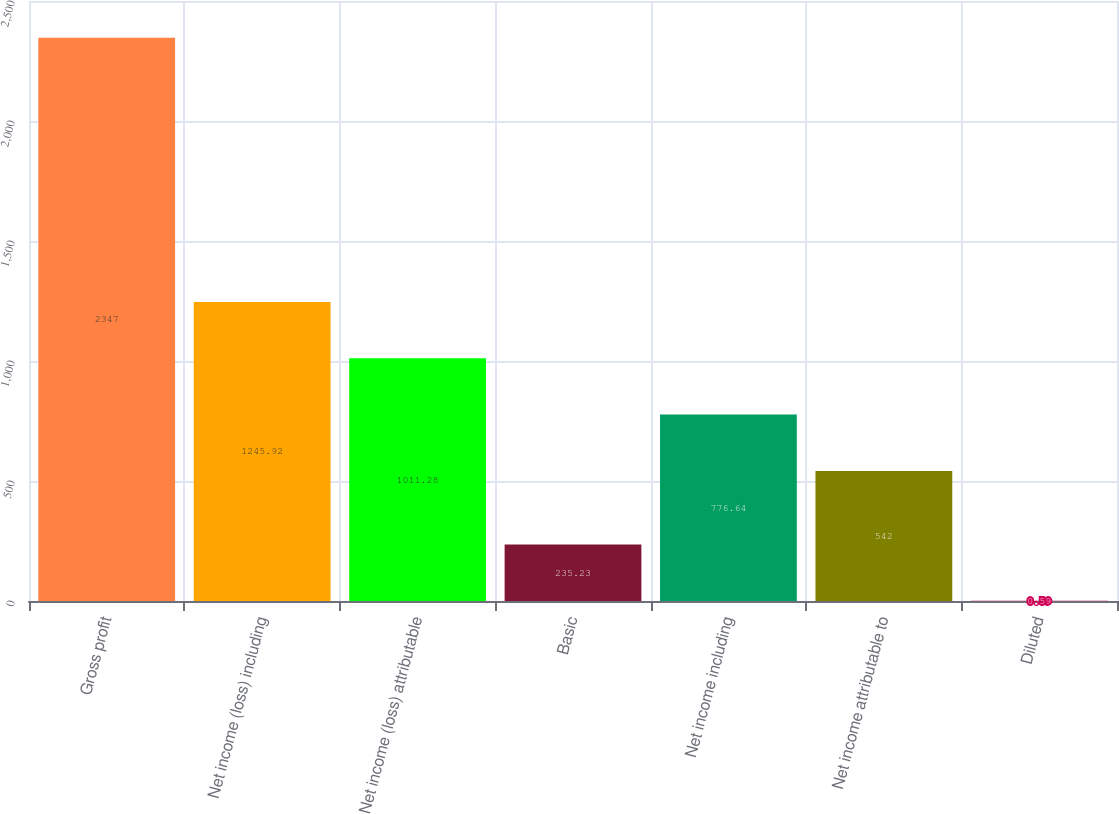Convert chart. <chart><loc_0><loc_0><loc_500><loc_500><bar_chart><fcel>Gross profit<fcel>Net income (loss) including<fcel>Net income (loss) attributable<fcel>Basic<fcel>Net income including<fcel>Net income attributable to<fcel>Diluted<nl><fcel>2347<fcel>1245.92<fcel>1011.28<fcel>235.23<fcel>776.64<fcel>542<fcel>0.59<nl></chart> 